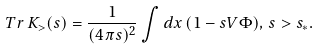<formula> <loc_0><loc_0><loc_500><loc_500>T r \, K _ { > } ( s ) = \frac { 1 } { ( 4 \pi s ) ^ { 2 } } \int d x \, ( 1 - s V \Phi ) , \, s > s _ { \ast } .</formula> 